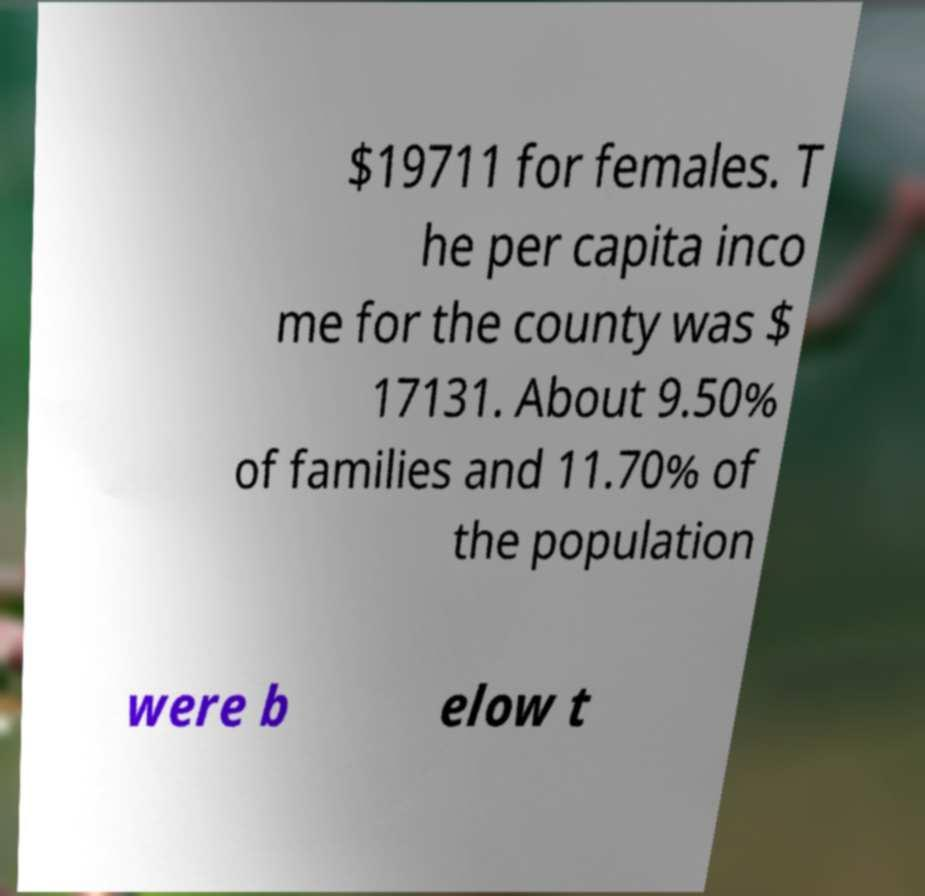What messages or text are displayed in this image? I need them in a readable, typed format. $19711 for females. T he per capita inco me for the county was $ 17131. About 9.50% of families and 11.70% of the population were b elow t 